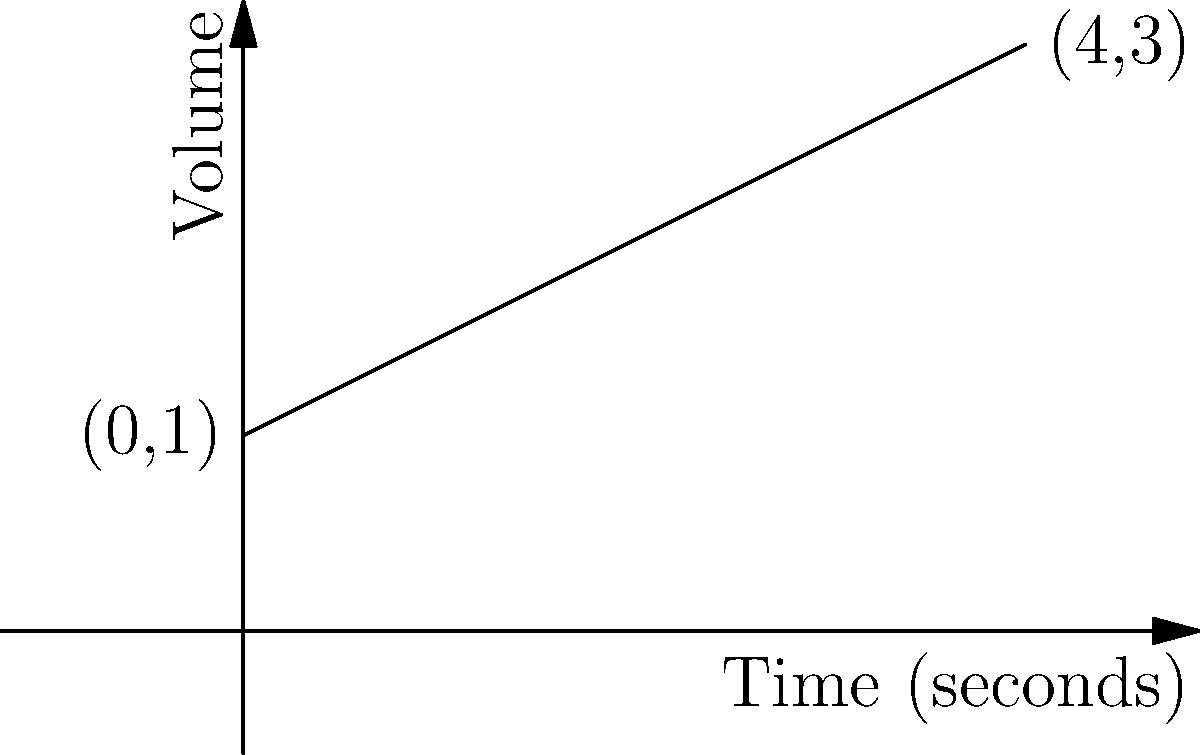A DJ is adjusting the volume fader during a performance. The graph shows the relationship between time and volume, with the initial volume at 1 and the final volume at 3 after 4 seconds. What is the rate of change of the volume with respect to time? To find the rate of change of volume with respect to time, we need to calculate the slope of the line in the graph. The slope represents the change in volume per unit of time.

Step 1: Identify two points on the line.
Point 1: (0, 1)
Point 2: (4, 3)

Step 2: Use the slope formula:
$$ m = \frac{y_2 - y_1}{x_2 - x_1} $$

Step 3: Plug in the values:
$$ m = \frac{3 - 1}{4 - 0} = \frac{2}{4} $$

Step 4: Simplify:
$$ m = 0.5 $$

This means the volume is increasing at a rate of 0.5 units per second.
Answer: 0.5 units/second 